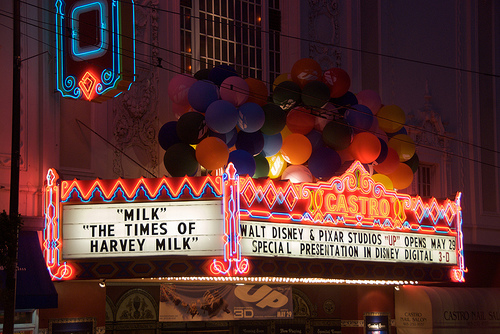<image>
Is there a ballons on the sign? Yes. Looking at the image, I can see the ballons is positioned on top of the sign, with the sign providing support. 